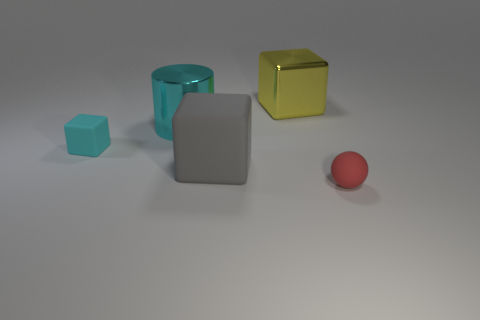How many other things are the same shape as the gray thing?
Offer a very short reply. 2. There is a large gray object; is it the same shape as the small thing that is behind the ball?
Your answer should be compact. Yes. What number of rubber things are to the left of the large cyan metal cylinder?
Your answer should be compact. 1. Is there a blue cube of the same size as the ball?
Your answer should be very brief. No. There is a small matte thing that is to the left of the yellow metal cube; is its shape the same as the large cyan shiny thing?
Provide a short and direct response. No. What color is the shiny cube?
Provide a short and direct response. Yellow. What shape is the large shiny thing that is the same color as the small matte cube?
Ensure brevity in your answer.  Cylinder. Are there any small red things?
Ensure brevity in your answer.  Yes. There is a yellow object that is the same material as the cyan cylinder; what is its size?
Your answer should be very brief. Large. What is the shape of the tiny matte object on the left side of the large block that is in front of the large cube behind the large cylinder?
Make the answer very short. Cube. 